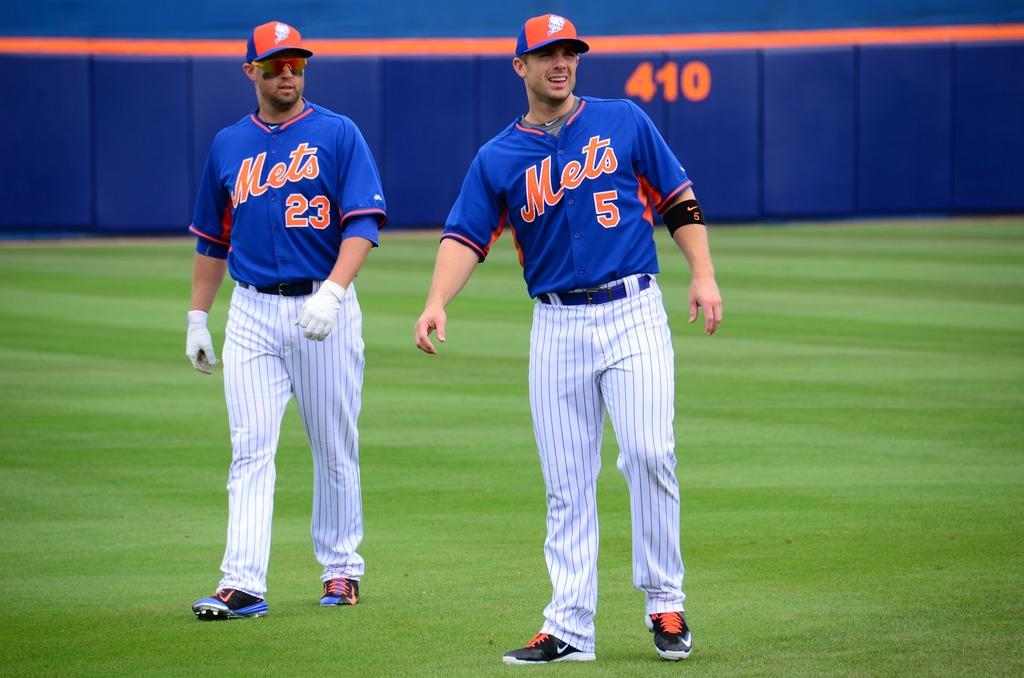What team do they play for?
Give a very brief answer. Mets. What is the player number on the left?
Offer a terse response. 23. 